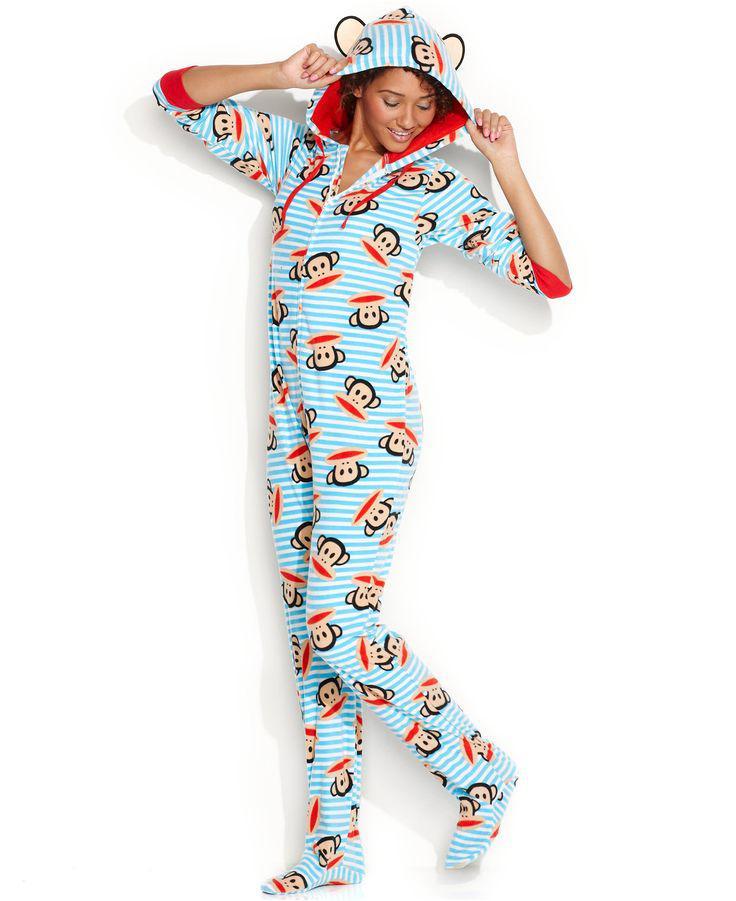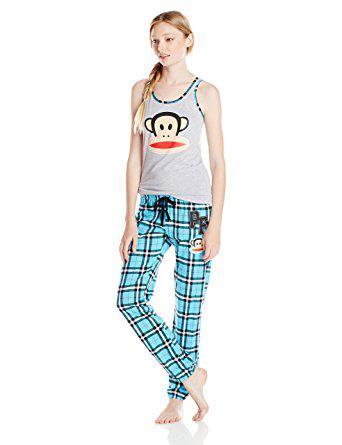The first image is the image on the left, the second image is the image on the right. Evaluate the accuracy of this statement regarding the images: "Pajama shirts in both images have sleeves the same length.". Is it true? Answer yes or no. No. 